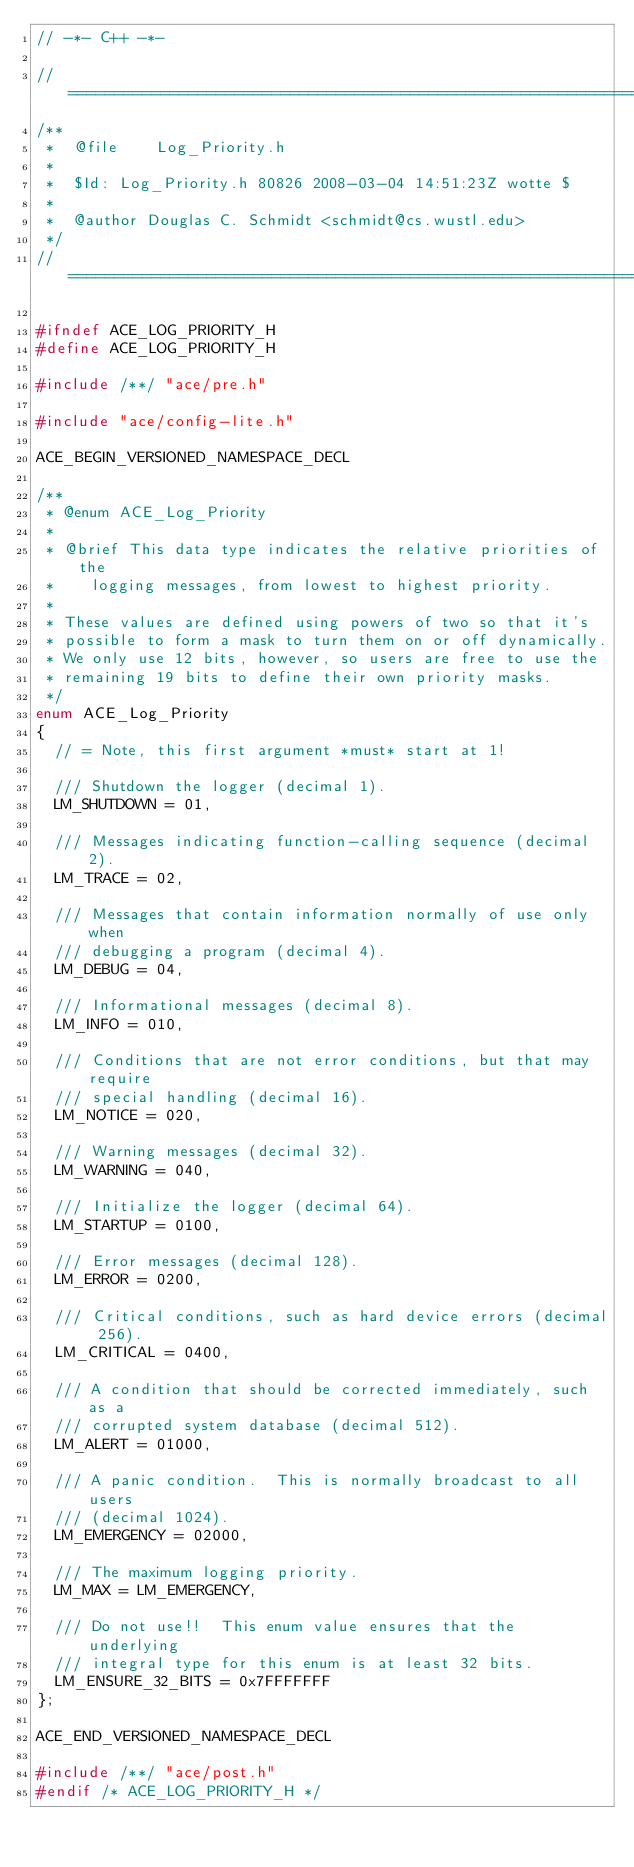<code> <loc_0><loc_0><loc_500><loc_500><_C_>// -*- C++ -*-

//=============================================================================
/**
 *  @file    Log_Priority.h
 *
 *  $Id: Log_Priority.h 80826 2008-03-04 14:51:23Z wotte $
 *
 *  @author Douglas C. Schmidt <schmidt@cs.wustl.edu>
 */
//=============================================================================

#ifndef ACE_LOG_PRIORITY_H
#define ACE_LOG_PRIORITY_H

#include /**/ "ace/pre.h"

#include "ace/config-lite.h"

ACE_BEGIN_VERSIONED_NAMESPACE_DECL

/**
 * @enum ACE_Log_Priority
 *
 * @brief This data type indicates the relative priorities of the
 *    logging messages, from lowest to highest priority.
 *
 * These values are defined using powers of two so that it's
 * possible to form a mask to turn them on or off dynamically.
 * We only use 12 bits, however, so users are free to use the
 * remaining 19 bits to define their own priority masks.
 */
enum ACE_Log_Priority
{
  // = Note, this first argument *must* start at 1!

  /// Shutdown the logger (decimal 1).
  LM_SHUTDOWN = 01,

  /// Messages indicating function-calling sequence (decimal 2).
  LM_TRACE = 02,

  /// Messages that contain information normally of use only when
  /// debugging a program (decimal 4).
  LM_DEBUG = 04,

  /// Informational messages (decimal 8).
  LM_INFO = 010,

  /// Conditions that are not error conditions, but that may require
  /// special handling (decimal 16).
  LM_NOTICE = 020,

  /// Warning messages (decimal 32).
  LM_WARNING = 040,

  /// Initialize the logger (decimal 64).
  LM_STARTUP = 0100,

  /// Error messages (decimal 128).
  LM_ERROR = 0200,

  /// Critical conditions, such as hard device errors (decimal 256).
  LM_CRITICAL = 0400,

  /// A condition that should be corrected immediately, such as a
  /// corrupted system database (decimal 512).
  LM_ALERT = 01000,

  /// A panic condition.  This is normally broadcast to all users
  /// (decimal 1024).
  LM_EMERGENCY = 02000,

  /// The maximum logging priority.
  LM_MAX = LM_EMERGENCY,

  /// Do not use!!  This enum value ensures that the underlying
  /// integral type for this enum is at least 32 bits.
  LM_ENSURE_32_BITS = 0x7FFFFFFF
};

ACE_END_VERSIONED_NAMESPACE_DECL

#include /**/ "ace/post.h"
#endif /* ACE_LOG_PRIORITY_H */
</code> 